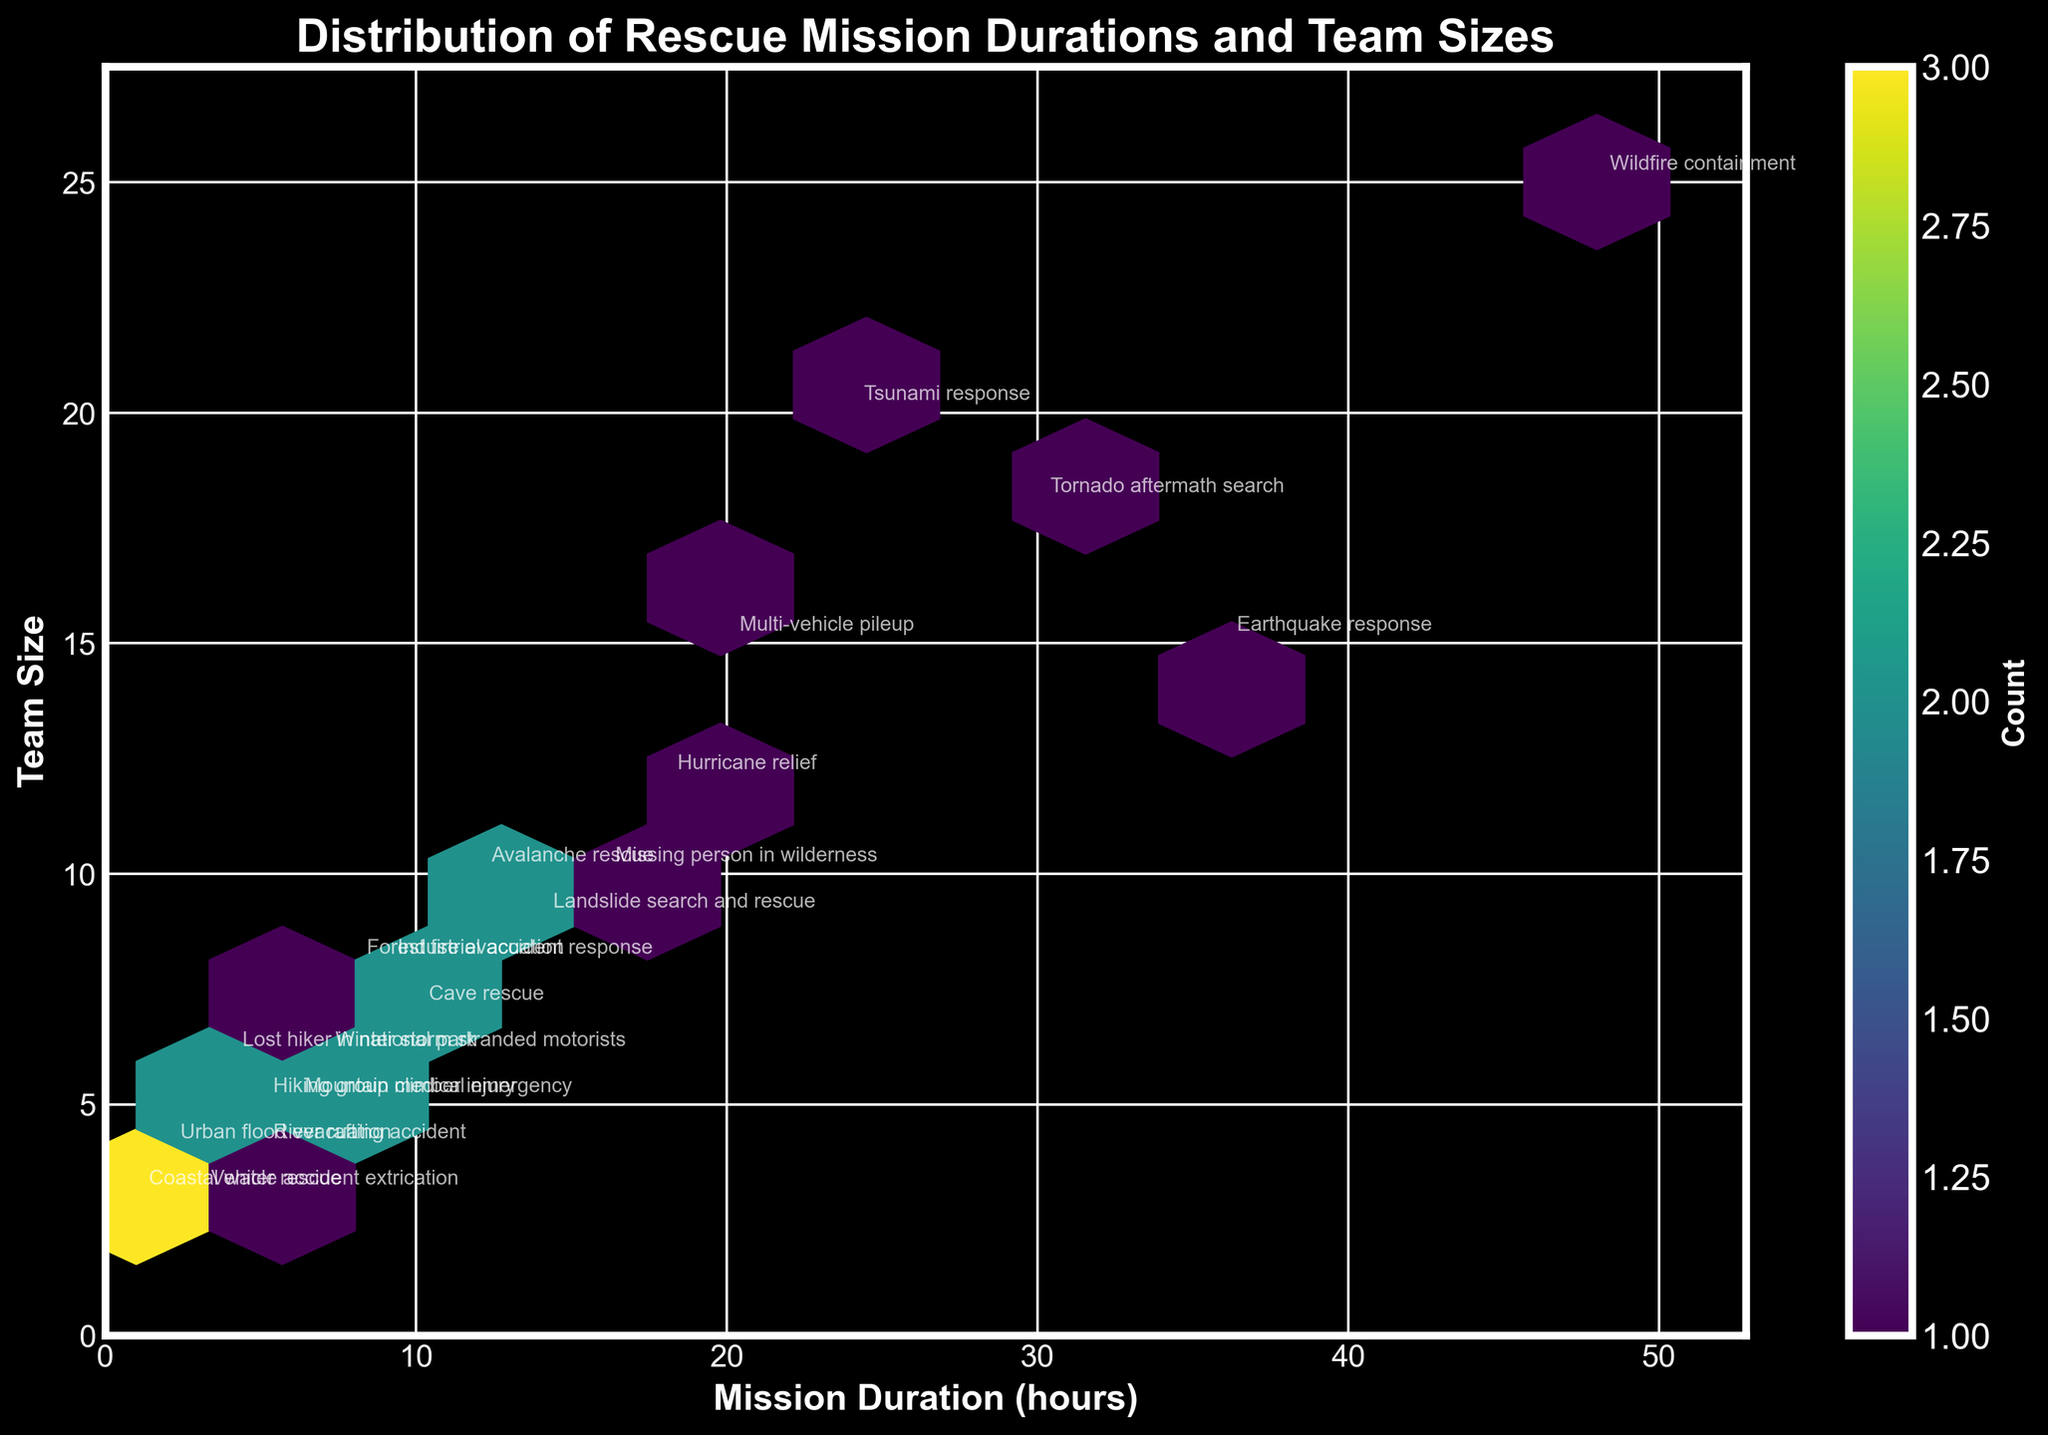What is the title of the plot? The title is shown at the top center of the plot. It reads "Distribution of Rescue Mission Durations and Team Sizes".
Answer: Distribution of Rescue Mission Durations and Team Sizes What do the x and y axes represent? The x-axis is labeled "Mission Duration (hours)" and the y-axis is labeled "Team Size". Therefore, the x-axis represents the duration of the rescue missions in hours, and the y-axis shows the size of the rescue teams.
Answer: Mission Duration (hours) and Team Size What is the color scale indicating in the plot? The color scale is represented by a color bar on the right side of the plot labeled "Count". The different shades indicate the number of instances or counts of rescue missions with particular durations and team sizes.
Answer: Count of rescue missions Which rescue mission scenario has the highest team size? Look for the data point with the highest y-axis value and read the annotation. The emergency scenario at the highest point on the y-axis is "Wildfire containment" with a team size of 25.
Answer: Wildfire containment How many rescue mission scenarios required a duration of more than 20 hours? Identify the scenarios by checking the x-axis points that are greater than 20 hours and count them. The scenarios are "Earthquake response", "Tsunami response", "Wildfire containment", "Tornado aftermath search", and "Multi-vehicle pileup".
Answer: 5 Which emergency scenario needed the smallest team size? Find the data point with the lowest y-axis value and read the annotation. The scenario with the smallest team size (team size of 3) are "Vehicle accident extrication" and "Coastal water rescue".
Answer: Vehicle accident extrication, Coastal water rescue What is the range of mission durations on the x-axis? The x-axis starts at 0 and ends at about 52.8 (which is 1.1 times 48, the maximum duration in the data). Thus, the range of mission durations is from 0 to approximately 52.8 hours.
Answer: 0 to 52.8 hours Which emergency scenarios fall within the 10-20 hours duration range? Check the x-axis points between 10 and 20 hours and read the annotations for those points. The scenarios are "Hurricane relief", "Landslide search and rescue", and "Missing person in wilderness".
Answer: Hurricane relief, Landslide search and rescue, Missing person in wilderness How does the team size correlate with increasing mission duration? Observing the plot, note the overall trend of data points. There's a general tendency for larger teams to be correlated with longer mission durations, indicating a positive correlation.
Answer: Positive correlation 